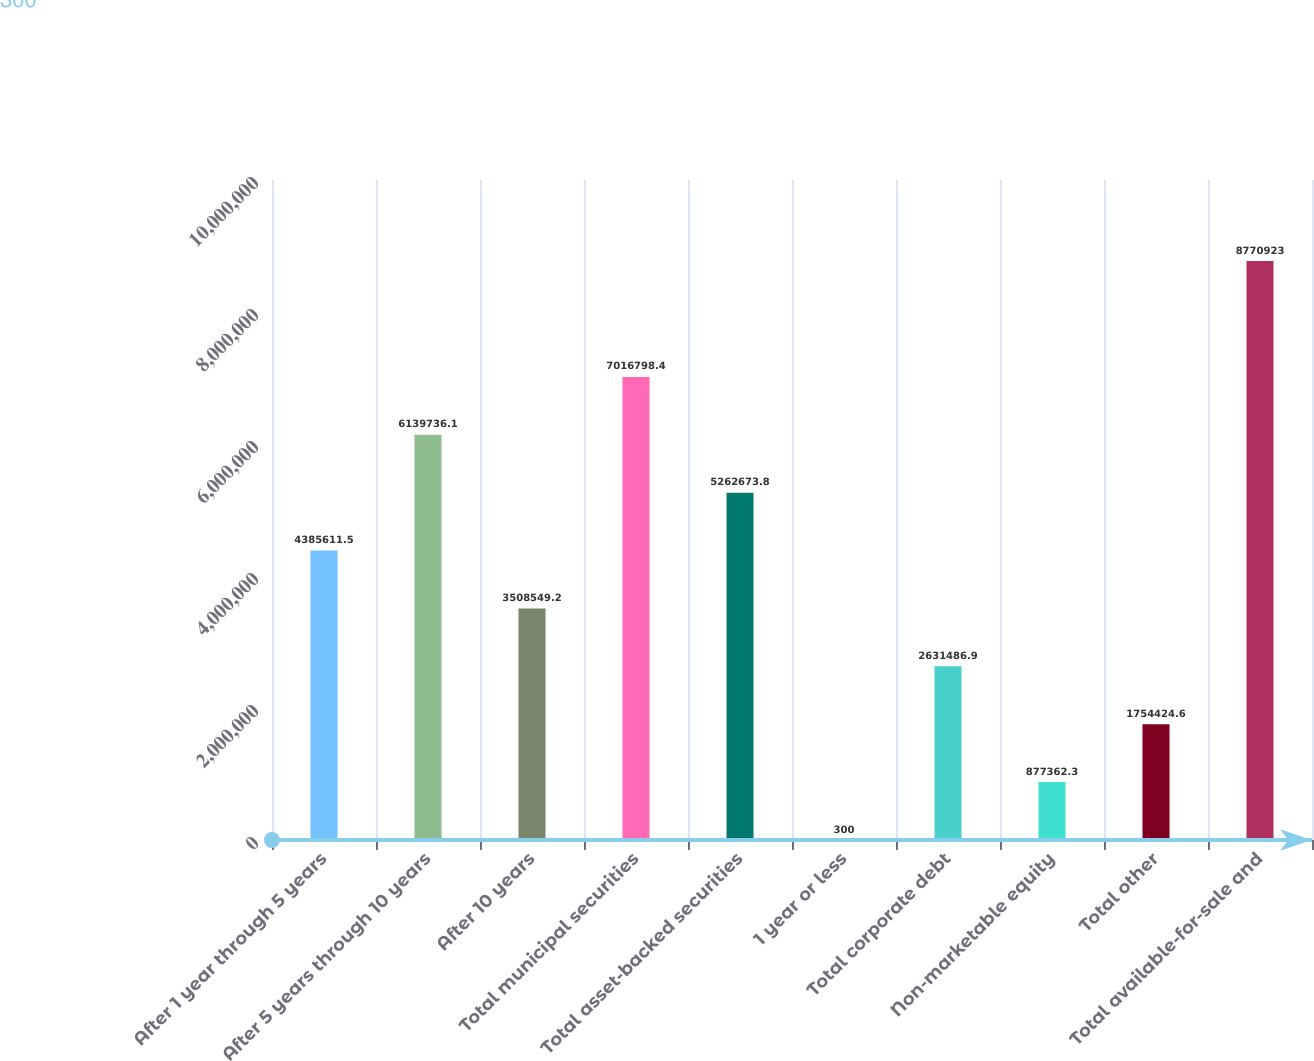<chart> <loc_0><loc_0><loc_500><loc_500><bar_chart><fcel>After 1 year through 5 years<fcel>After 5 years through 10 years<fcel>After 10 years<fcel>Total municipal securities<fcel>Total asset-backed securities<fcel>1 year or less<fcel>Total corporate debt<fcel>Non-marketable equity<fcel>Total other<fcel>Total available-for-sale and<nl><fcel>4.38561e+06<fcel>6.13974e+06<fcel>3.50855e+06<fcel>7.0168e+06<fcel>5.26267e+06<fcel>300<fcel>2.63149e+06<fcel>877362<fcel>1.75442e+06<fcel>8.77092e+06<nl></chart> 